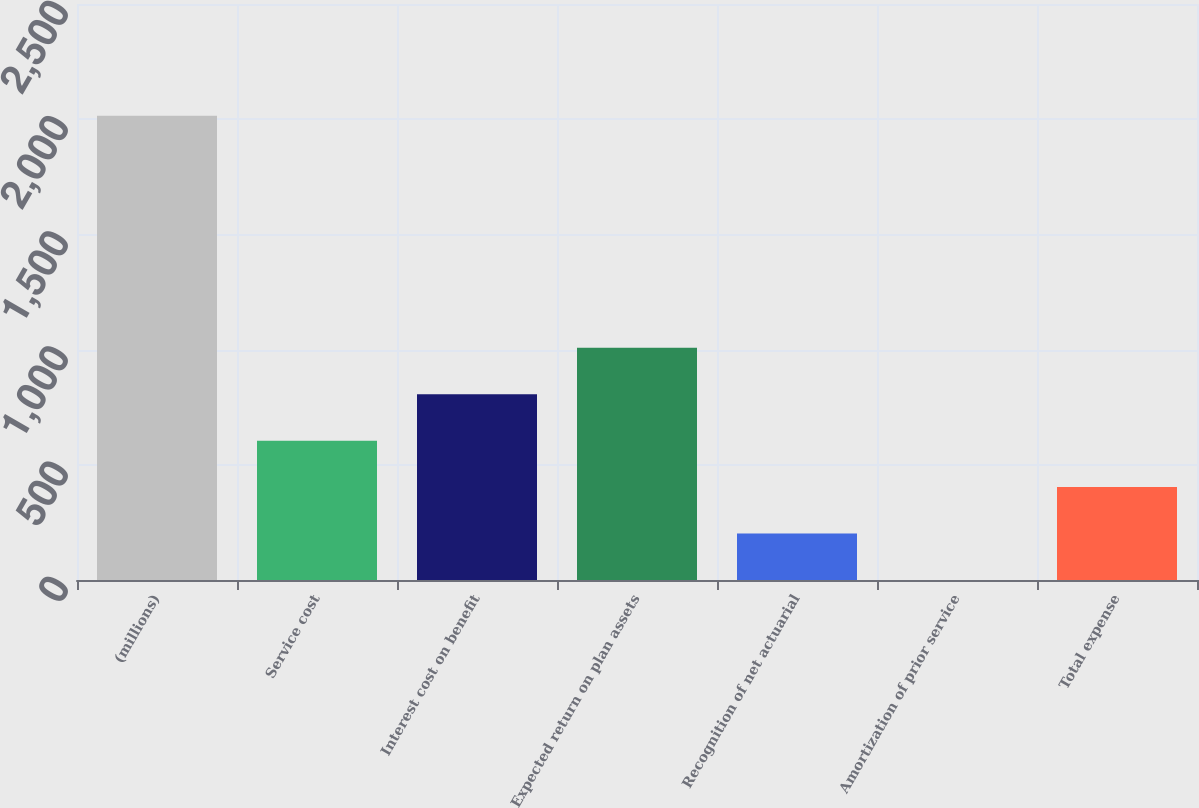Convert chart to OTSL. <chart><loc_0><loc_0><loc_500><loc_500><bar_chart><fcel>(millions)<fcel>Service cost<fcel>Interest cost on benefit<fcel>Expected return on plan assets<fcel>Recognition of net actuarial<fcel>Amortization of prior service<fcel>Total expense<nl><fcel>2015<fcel>604.78<fcel>806.24<fcel>1007.7<fcel>201.86<fcel>0.4<fcel>403.32<nl></chart> 